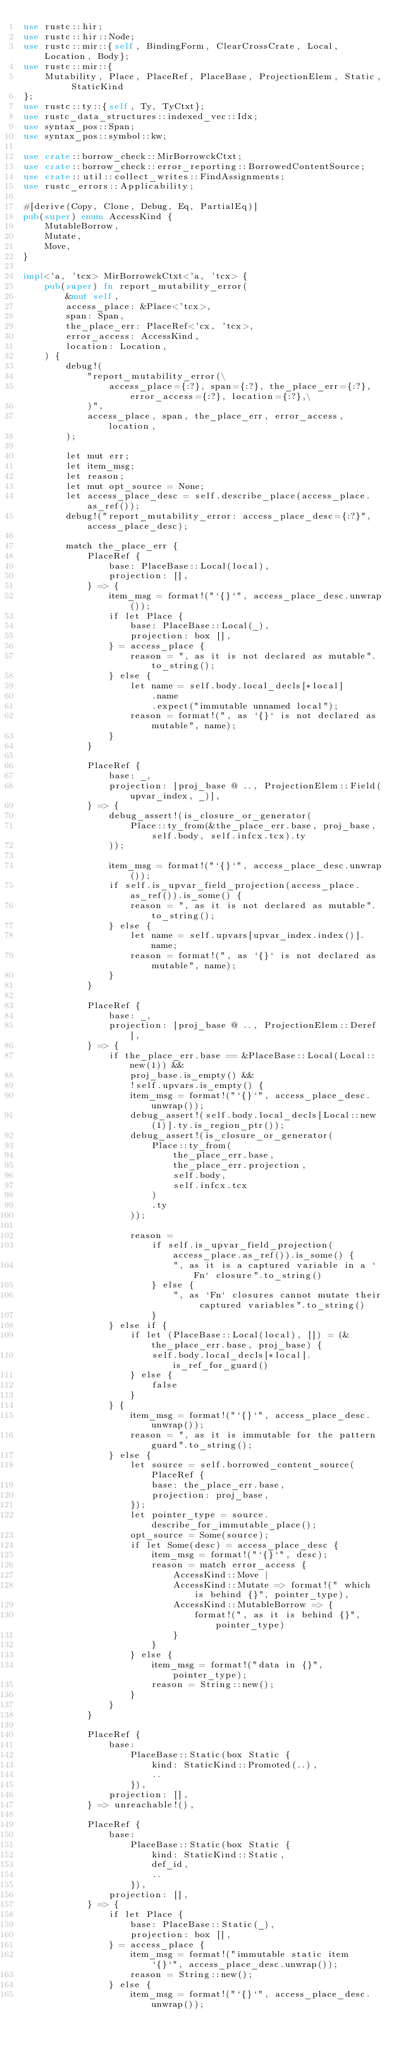<code> <loc_0><loc_0><loc_500><loc_500><_Rust_>use rustc::hir;
use rustc::hir::Node;
use rustc::mir::{self, BindingForm, ClearCrossCrate, Local, Location, Body};
use rustc::mir::{
    Mutability, Place, PlaceRef, PlaceBase, ProjectionElem, Static, StaticKind
};
use rustc::ty::{self, Ty, TyCtxt};
use rustc_data_structures::indexed_vec::Idx;
use syntax_pos::Span;
use syntax_pos::symbol::kw;

use crate::borrow_check::MirBorrowckCtxt;
use crate::borrow_check::error_reporting::BorrowedContentSource;
use crate::util::collect_writes::FindAssignments;
use rustc_errors::Applicability;

#[derive(Copy, Clone, Debug, Eq, PartialEq)]
pub(super) enum AccessKind {
    MutableBorrow,
    Mutate,
    Move,
}

impl<'a, 'tcx> MirBorrowckCtxt<'a, 'tcx> {
    pub(super) fn report_mutability_error(
        &mut self,
        access_place: &Place<'tcx>,
        span: Span,
        the_place_err: PlaceRef<'cx, 'tcx>,
        error_access: AccessKind,
        location: Location,
    ) {
        debug!(
            "report_mutability_error(\
                access_place={:?}, span={:?}, the_place_err={:?}, error_access={:?}, location={:?},\
            )",
            access_place, span, the_place_err, error_access, location,
        );

        let mut err;
        let item_msg;
        let reason;
        let mut opt_source = None;
        let access_place_desc = self.describe_place(access_place.as_ref());
        debug!("report_mutability_error: access_place_desc={:?}", access_place_desc);

        match the_place_err {
            PlaceRef {
                base: PlaceBase::Local(local),
                projection: [],
            } => {
                item_msg = format!("`{}`", access_place_desc.unwrap());
                if let Place {
                    base: PlaceBase::Local(_),
                    projection: box [],
                } = access_place {
                    reason = ", as it is not declared as mutable".to_string();
                } else {
                    let name = self.body.local_decls[*local]
                        .name
                        .expect("immutable unnamed local");
                    reason = format!(", as `{}` is not declared as mutable", name);
                }
            }

            PlaceRef {
                base: _,
                projection: [proj_base @ .., ProjectionElem::Field(upvar_index, _)],
            } => {
                debug_assert!(is_closure_or_generator(
                    Place::ty_from(&the_place_err.base, proj_base, self.body, self.infcx.tcx).ty
                ));

                item_msg = format!("`{}`", access_place_desc.unwrap());
                if self.is_upvar_field_projection(access_place.as_ref()).is_some() {
                    reason = ", as it is not declared as mutable".to_string();
                } else {
                    let name = self.upvars[upvar_index.index()].name;
                    reason = format!(", as `{}` is not declared as mutable", name);
                }
            }

            PlaceRef {
                base: _,
                projection: [proj_base @ .., ProjectionElem::Deref],
            } => {
                if the_place_err.base == &PlaceBase::Local(Local::new(1)) &&
                    proj_base.is_empty() &&
                    !self.upvars.is_empty() {
                    item_msg = format!("`{}`", access_place_desc.unwrap());
                    debug_assert!(self.body.local_decls[Local::new(1)].ty.is_region_ptr());
                    debug_assert!(is_closure_or_generator(
                        Place::ty_from(
                            the_place_err.base,
                            the_place_err.projection,
                            self.body,
                            self.infcx.tcx
                        )
                        .ty
                    ));

                    reason =
                        if self.is_upvar_field_projection(access_place.as_ref()).is_some() {
                            ", as it is a captured variable in a `Fn` closure".to_string()
                        } else {
                            ", as `Fn` closures cannot mutate their captured variables".to_string()
                        }
                } else if {
                    if let (PlaceBase::Local(local), []) = (&the_place_err.base, proj_base) {
                        self.body.local_decls[*local].is_ref_for_guard()
                    } else {
                        false
                    }
                } {
                    item_msg = format!("`{}`", access_place_desc.unwrap());
                    reason = ", as it is immutable for the pattern guard".to_string();
                } else {
                    let source = self.borrowed_content_source(PlaceRef {
                        base: the_place_err.base,
                        projection: proj_base,
                    });
                    let pointer_type = source.describe_for_immutable_place();
                    opt_source = Some(source);
                    if let Some(desc) = access_place_desc {
                        item_msg = format!("`{}`", desc);
                        reason = match error_access {
                            AccessKind::Move |
                            AccessKind::Mutate => format!(" which is behind {}", pointer_type),
                            AccessKind::MutableBorrow => {
                                format!(", as it is behind {}", pointer_type)
                            }
                        }
                    } else {
                        item_msg = format!("data in {}", pointer_type);
                        reason = String::new();
                    }
                }
            }

            PlaceRef {
                base:
                    PlaceBase::Static(box Static {
                        kind: StaticKind::Promoted(..),
                        ..
                    }),
                projection: [],
            } => unreachable!(),

            PlaceRef {
                base:
                    PlaceBase::Static(box Static {
                        kind: StaticKind::Static,
                        def_id,
                        ..
                    }),
                projection: [],
            } => {
                if let Place {
                    base: PlaceBase::Static(_),
                    projection: box [],
                } = access_place {
                    item_msg = format!("immutable static item `{}`", access_place_desc.unwrap());
                    reason = String::new();
                } else {
                    item_msg = format!("`{}`", access_place_desc.unwrap());</code> 